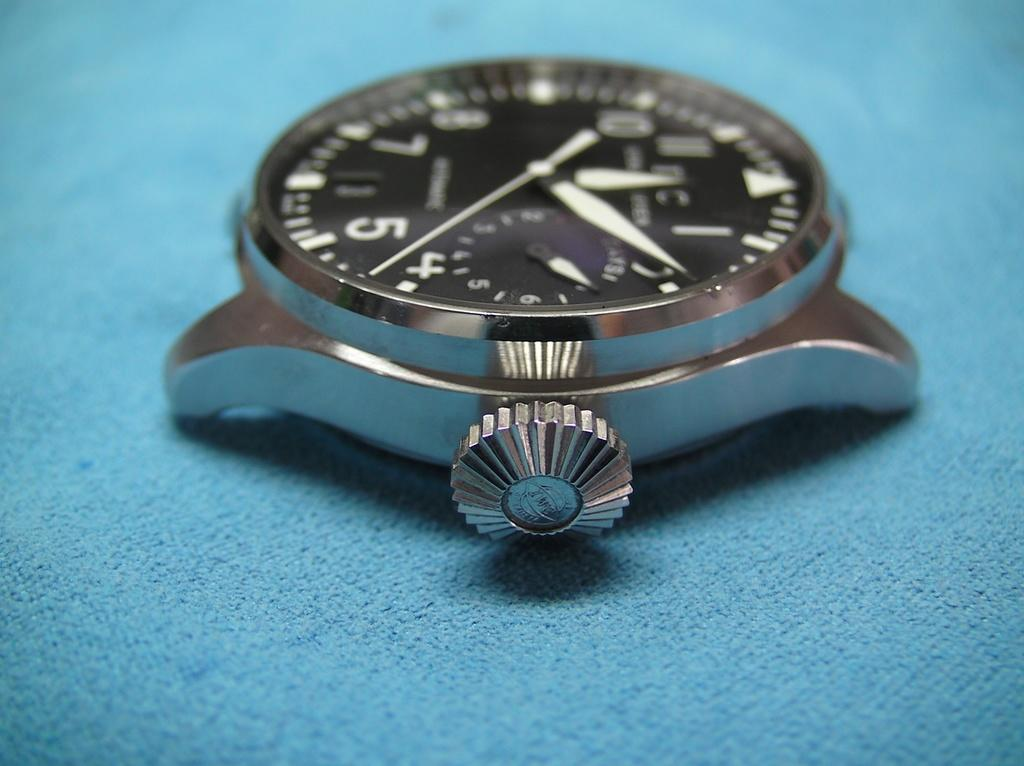<image>
Offer a succinct explanation of the picture presented. A watch with the seconds hand between 4 and 5 